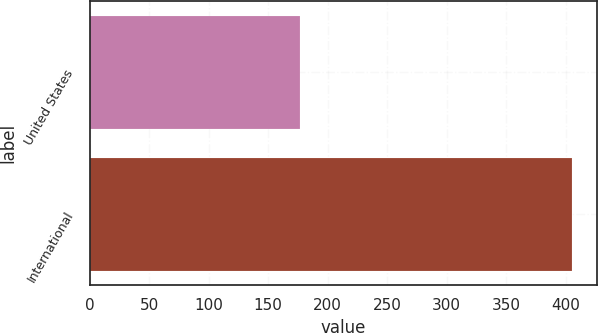<chart> <loc_0><loc_0><loc_500><loc_500><bar_chart><fcel>United States<fcel>International<nl><fcel>176.5<fcel>405.5<nl></chart> 